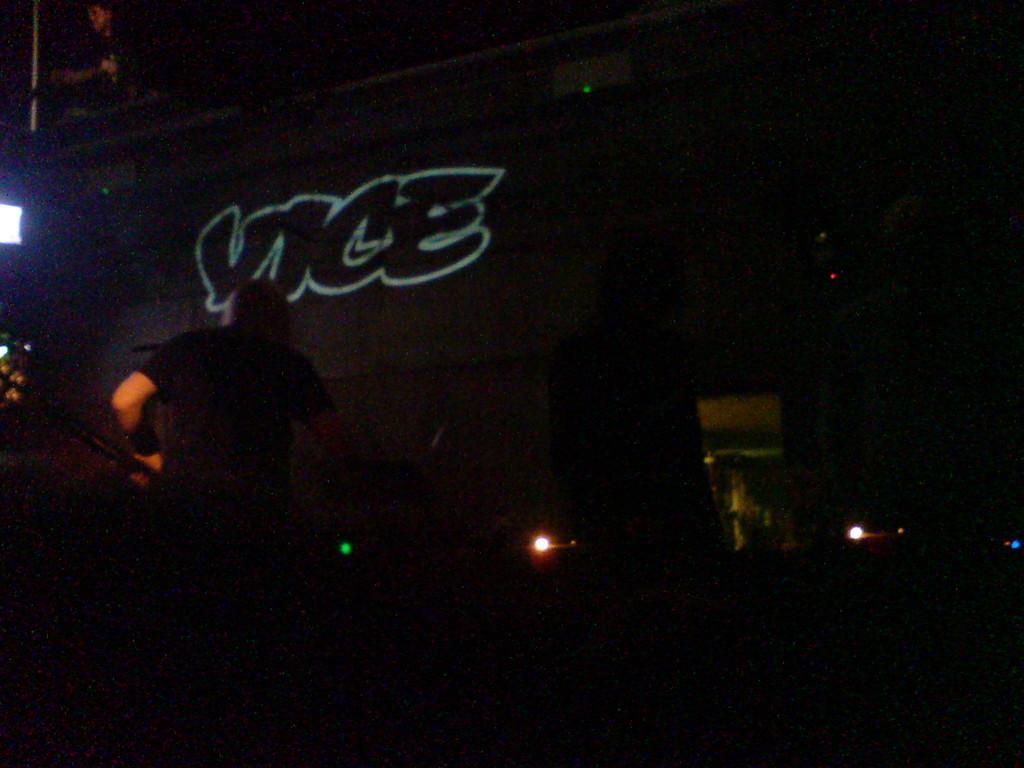How would you describe the overall lighting in the image? The image is dark. Can you identify any people in the image? Yes, there is a man standing near the wall. Is there any source of light visible in the image? Yes, there is a light on the left side of the image. What type of tail can be seen on the man in the image? There is no tail visible on the man in the image. How does the cover of the wall affect the lighting in the image? The provided facts do not mention a cover on the wall, so we cannot determine its effect on the lighting in the image. 